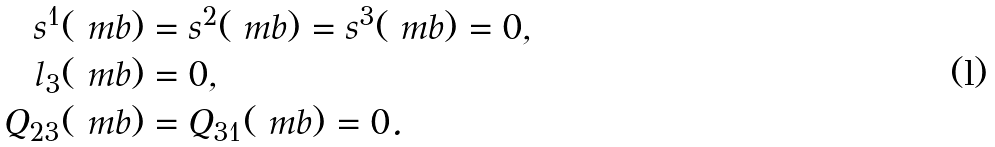<formula> <loc_0><loc_0><loc_500><loc_500>s ^ { 1 } ( \ m b ) & = s ^ { 2 } ( \ m b ) = s ^ { 3 } ( \ m b ) = 0 , \\ l _ { 3 } ( \ m b ) & = 0 , \\ Q _ { 2 3 } ( \ m b ) & = Q _ { 3 1 } ( \ m b ) = 0 .</formula> 